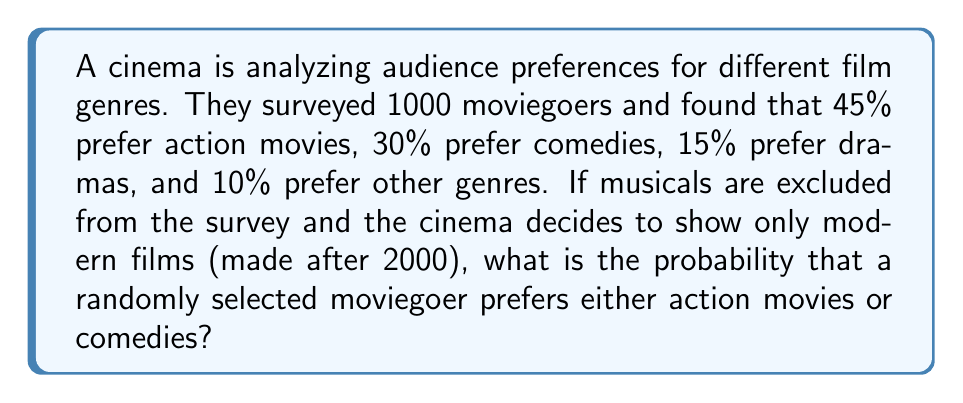Help me with this question. Let's approach this step-by-step:

1) First, we need to identify the relevant information:
   - Total surveyed: 1000
   - Action preference: 45%
   - Comedy preference: 30%
   - Musicals are excluded (which aligns with the persona)
   - Only modern films are considered (also aligns with the persona)

2) The question asks for the probability of preferring either action movies or comedies. In probability theory, this is the union of two events.

3) The probability of preferring action movies is:
   $P(Action) = 0.45$

4) The probability of preferring comedies is:
   $P(Comedy) = 0.30$

5) To find the probability of preferring either action or comedy, we add these probabilities:
   $P(Action \cup Comedy) = P(Action) + P(Comedy)$

6) Substituting the values:
   $P(Action \cup Comedy) = 0.45 + 0.30 = 0.75$

7) Therefore, the probability is 0.75 or 75%.

Note: We don't need to consider the other genres or the total number of people surveyed because we're working with percentages, which already account for the total population.
Answer: 0.75 